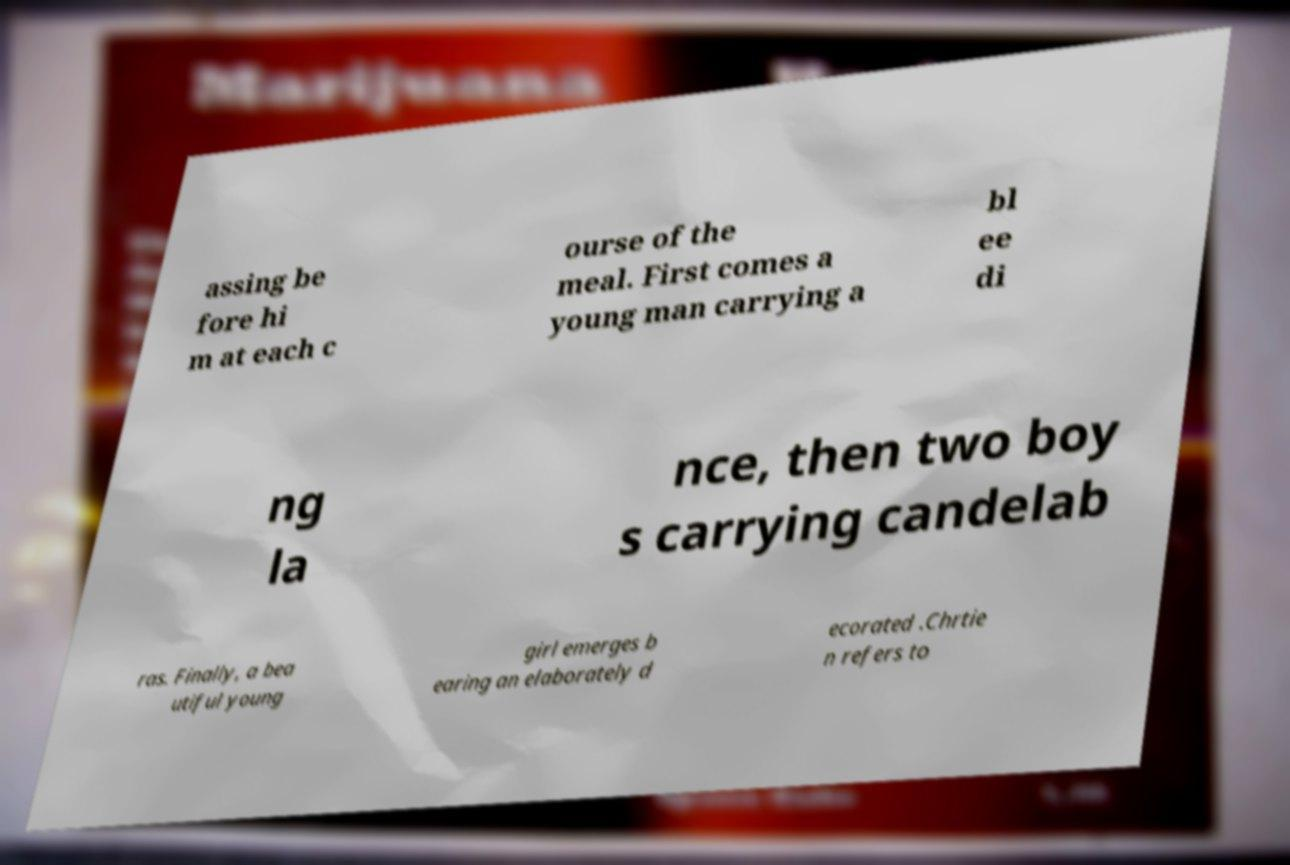I need the written content from this picture converted into text. Can you do that? assing be fore hi m at each c ourse of the meal. First comes a young man carrying a bl ee di ng la nce, then two boy s carrying candelab ras. Finally, a bea utiful young girl emerges b earing an elaborately d ecorated .Chrtie n refers to 